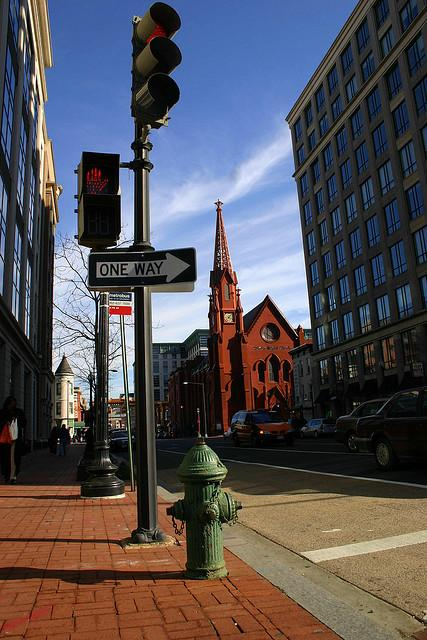Which way can those cars turn? Please explain your reasoning. their left. The sign is facing right which is the car driver's left. 